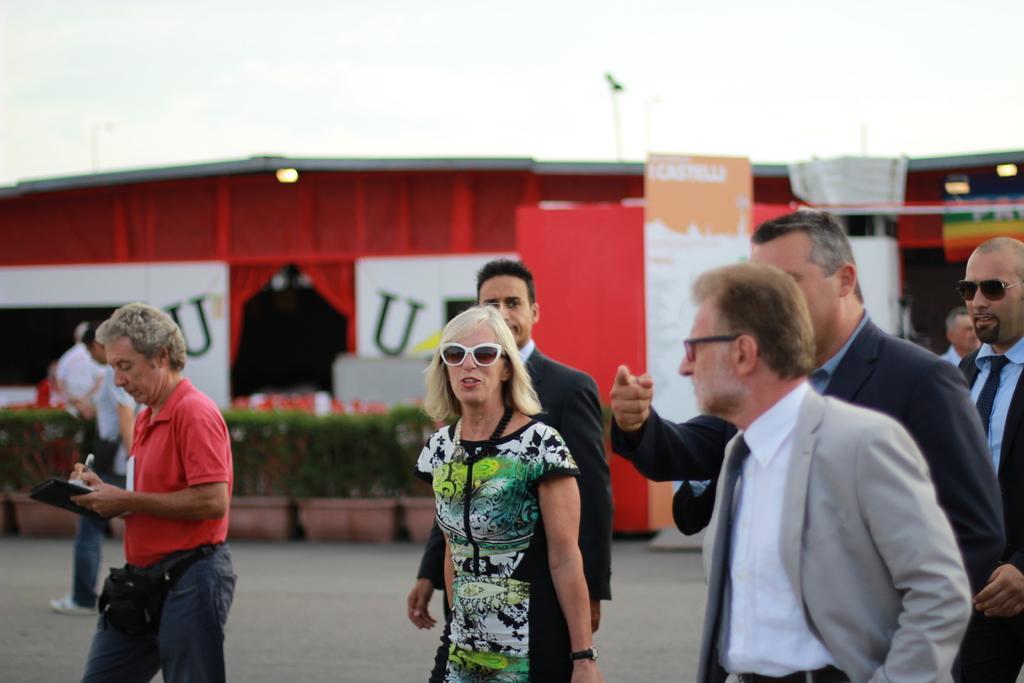How would you summarize this image in a sentence or two? In the picture there are a group of people and behind them there is some compartment, it is of red color and in front of that compartment there are few plants. 